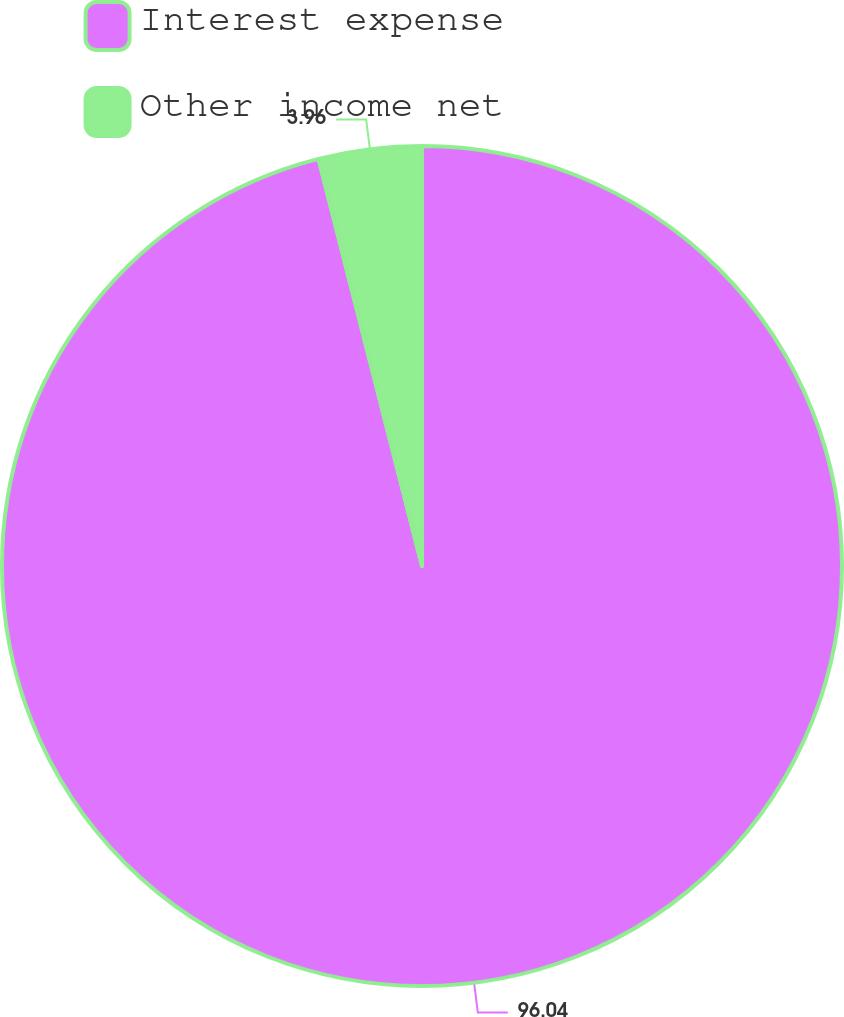Convert chart. <chart><loc_0><loc_0><loc_500><loc_500><pie_chart><fcel>Interest expense<fcel>Other income net<nl><fcel>96.04%<fcel>3.96%<nl></chart> 